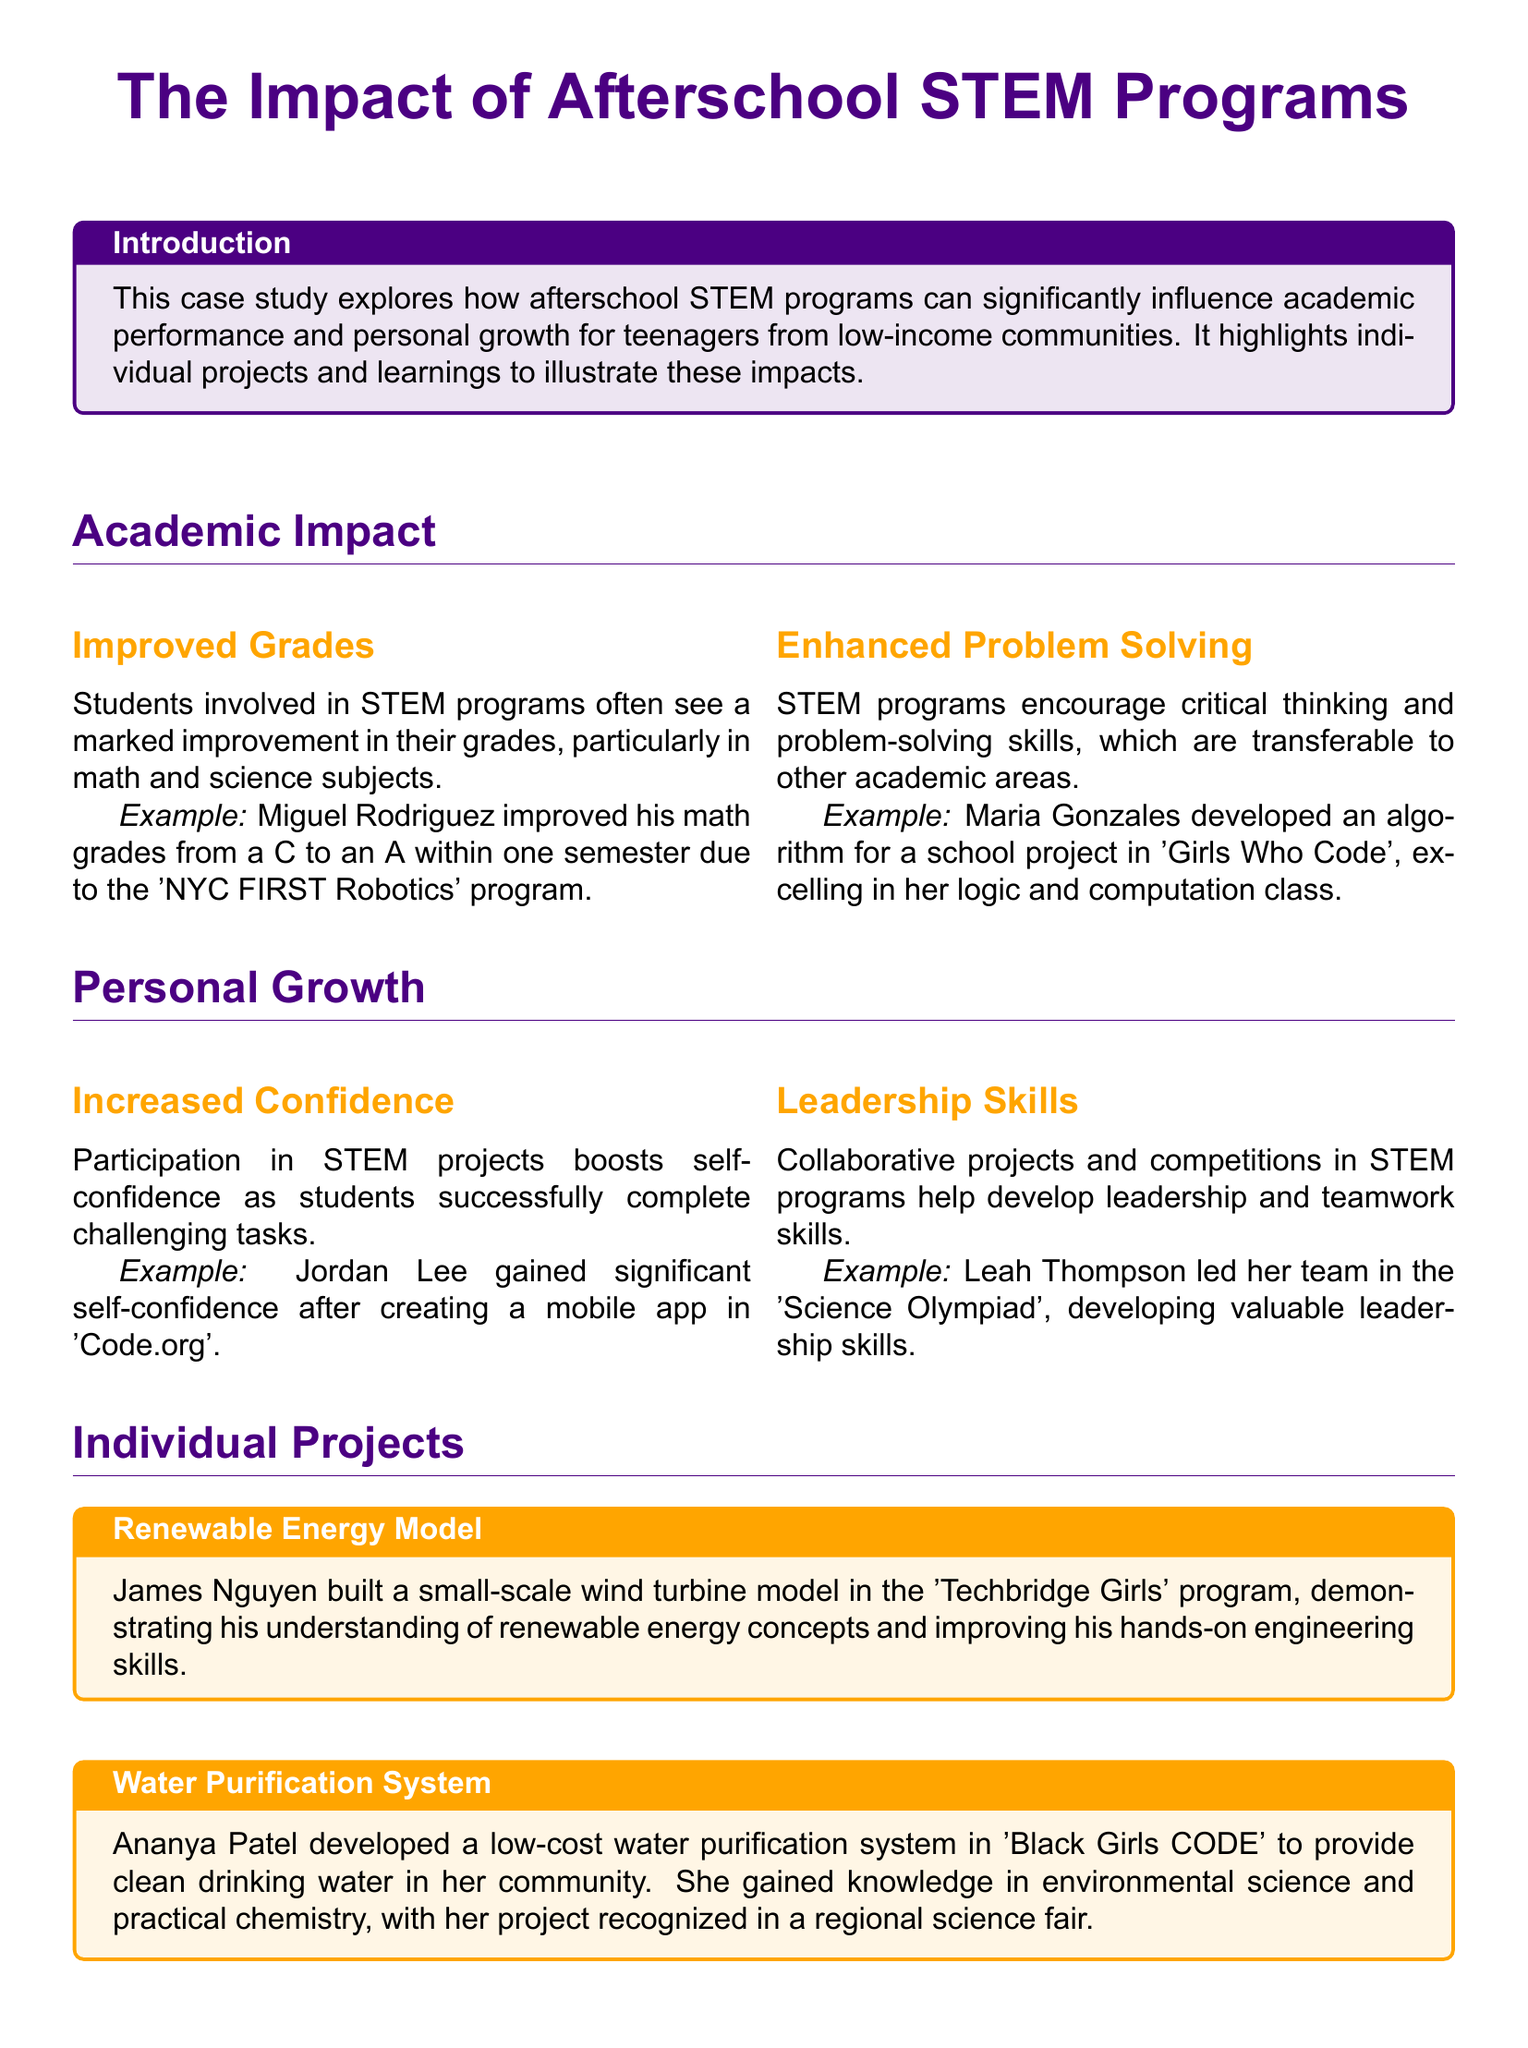What is the title of the case study? The title of the case study is presented at the beginning, highlighting the focus of the document.
Answer: The Impact of Afterschool STEM Programs Who improved their math grades from a C to an A? This information is provided in the section discussing the academic impact of STEM programs through a specific example.
Answer: Miguel Rodriguez What did Ananya Patel develop? This is mentioned in the individual projects section which describes her work relevant to community needs.
Answer: Low-cost water purification system What program did Jordan Lee participate in? This detail is found under the personal growth section, indicating his involvement in a specific program.
Answer: Code.org What skills did Leah Thompson develop? The document highlights her leadership role in a competition, indicating the skills she enhanced through the experience.
Answer: Leadership skills How can afterschool STEM programs impact students? This question requires synthesizing the overall conclusion about the potential benefits of these programs.
Answer: Academic performance and personal growth What was a notable outcome of James Nguyen's project? This result showcases the practical understanding gained following his engagement with the program mentioned.
Answer: Improving hands-on engineering skills What type of projects are highlighted in the case study? The document specifies the nature of the projects to support its claims about personal and academic development.
Answer: Hands-on projects In which community are the benefits of STEM programs particularly emphasized? The document repeatedly mentions the target demographic benefiting from the programs.
Answer: Low-income communities 